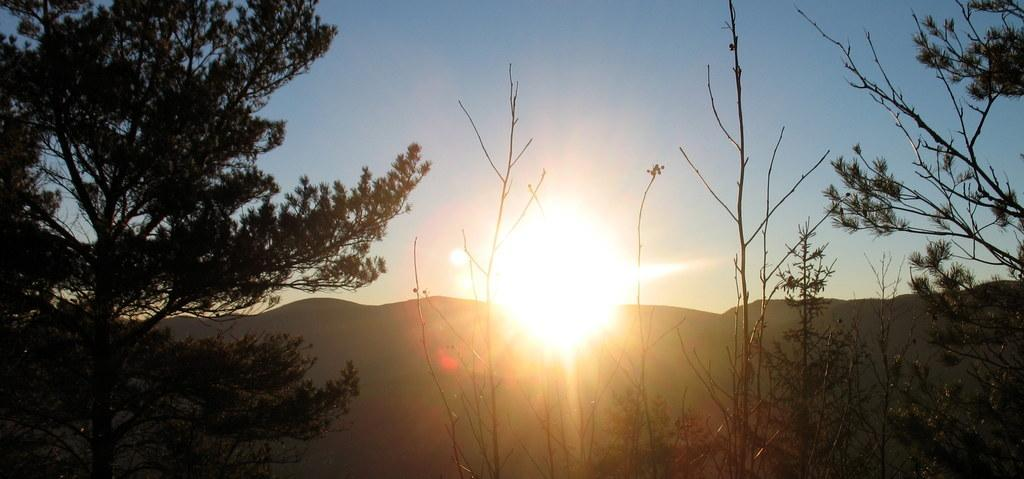What types of vegetation are in the foreground of the picture? There are plants and trees in the foreground of the picture. What geographical features are in the center of the picture? There are hills in the center of the picture. What celestial body is visible in the background of the picture? The sun is visible in the background. What is the condition of the sky in the picture? The sky is clear in the picture. How does the health of the plants in the picture affect the yard? The provided facts do not mention any yard or the health of the plants, so it is not possible to answer this question. 